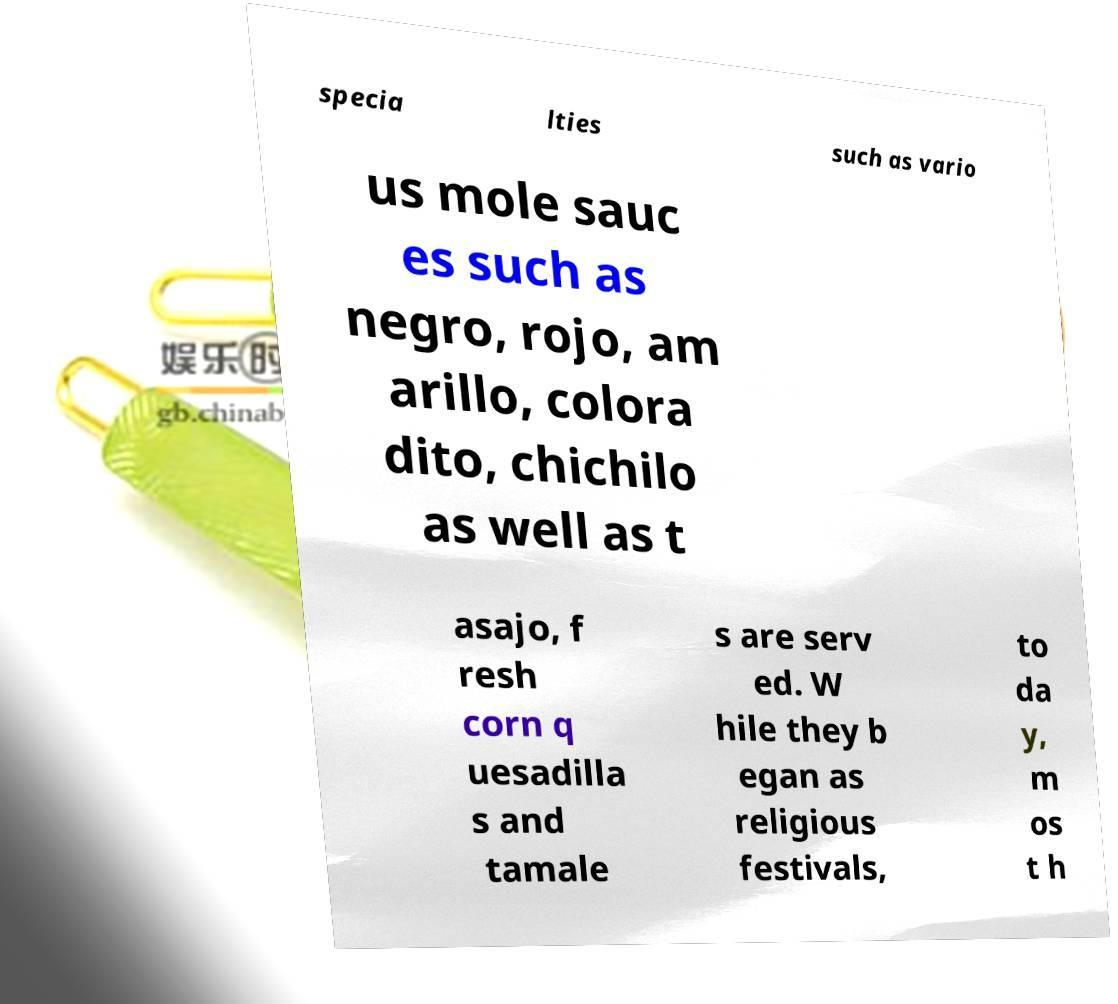Can you read and provide the text displayed in the image?This photo seems to have some interesting text. Can you extract and type it out for me? specia lties such as vario us mole sauc es such as negro, rojo, am arillo, colora dito, chichilo as well as t asajo, f resh corn q uesadilla s and tamale s are serv ed. W hile they b egan as religious festivals, to da y, m os t h 